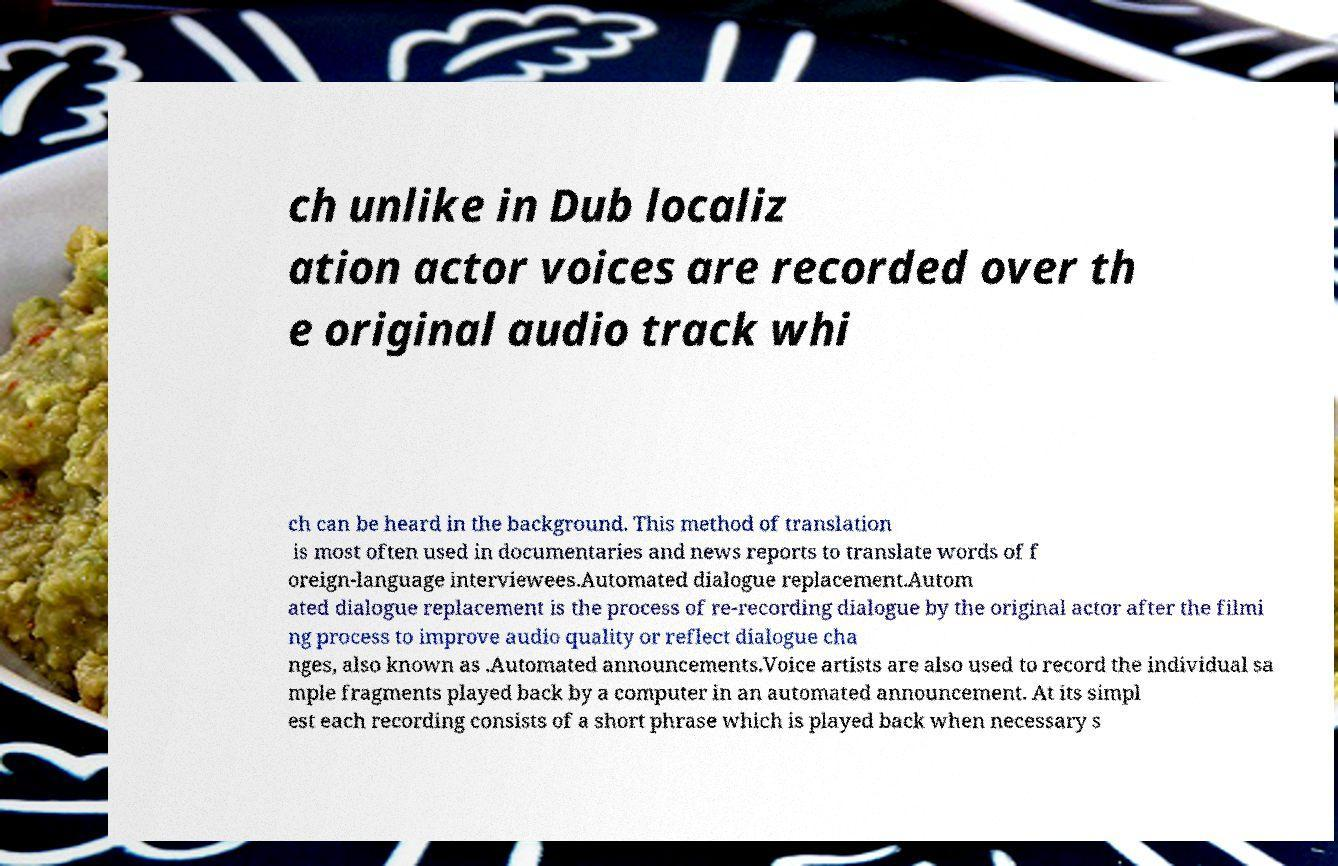There's text embedded in this image that I need extracted. Can you transcribe it verbatim? ch unlike in Dub localiz ation actor voices are recorded over th e original audio track whi ch can be heard in the background. This method of translation is most often used in documentaries and news reports to translate words of f oreign-language interviewees.Automated dialogue replacement.Autom ated dialogue replacement is the process of re-recording dialogue by the original actor after the filmi ng process to improve audio quality or reflect dialogue cha nges, also known as .Automated announcements.Voice artists are also used to record the individual sa mple fragments played back by a computer in an automated announcement. At its simpl est each recording consists of a short phrase which is played back when necessary s 